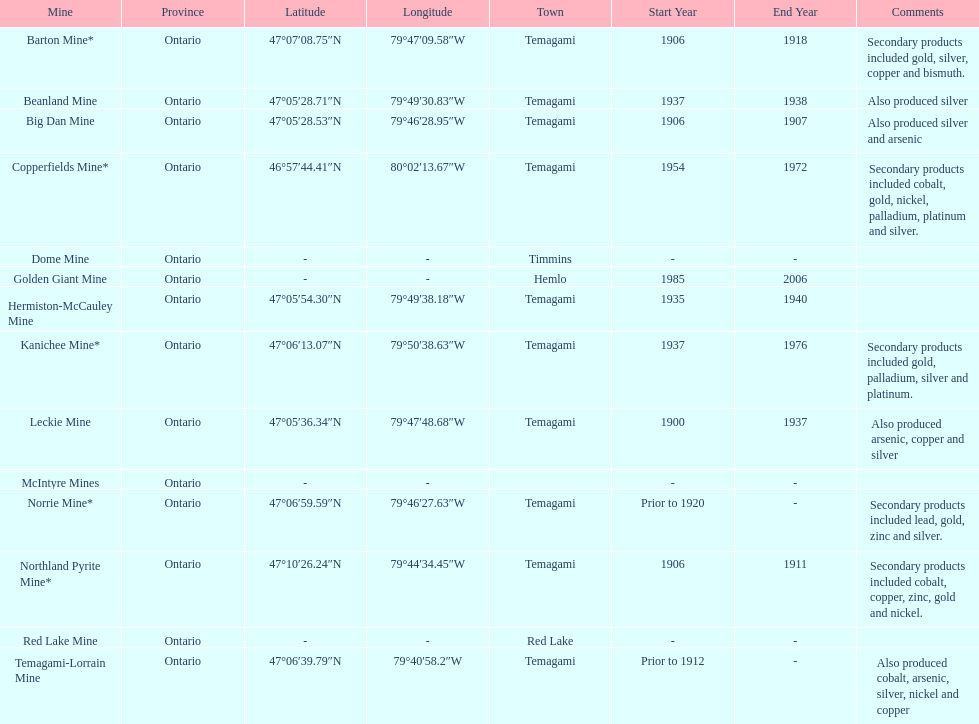Write the full table. {'header': ['Mine', 'Province', 'Latitude', 'Longitude', 'Town', 'Start Year', 'End Year', 'Comments'], 'rows': [['Barton Mine*', 'Ontario', '47°07′08.75″N', '79°47′09.58″W', 'Temagami', '1906', '1918', 'Secondary products included gold, silver, copper and bismuth.'], ['Beanland Mine', 'Ontario', '47°05′28.71″N', '79°49′30.83″W', 'Temagami', '1937', '1938', 'Also produced silver'], ['Big Dan Mine', 'Ontario', '47°05′28.53″N', '79°46′28.95″W', 'Temagami', '1906', '1907', 'Also produced silver and arsenic'], ['Copperfields Mine*', 'Ontario', '46°57′44.41″N', '80°02′13.67″W', 'Temagami', '1954', '1972', 'Secondary products included cobalt, gold, nickel, palladium, platinum and silver.'], ['Dome Mine', 'Ontario', '-', '-', 'Timmins', '-', '-', ''], ['Golden Giant Mine', 'Ontario', '-', '-', 'Hemlo', '1985', '2006', ''], ['Hermiston-McCauley Mine', 'Ontario', '47°05′54.30″N', '79°49′38.18″W', 'Temagami', '1935', '1940', ''], ['Kanichee Mine*', 'Ontario', '47°06′13.07″N', '79°50′38.63″W', 'Temagami', '1937', '1976', 'Secondary products included gold, palladium, silver and platinum.'], ['Leckie Mine', 'Ontario', '47°05′36.34″N', '79°47′48.68″W', 'Temagami', '1900', '1937', 'Also produced arsenic, copper and silver'], ['McIntyre Mines', 'Ontario', '-', '-', '', '-', '-', ''], ['Norrie Mine*', 'Ontario', '47°06′59.59″N', '79°46′27.63″W', 'Temagami', 'Prior to 1920', '-', 'Secondary products included lead, gold, zinc and silver.'], ['Northland Pyrite Mine*', 'Ontario', '47°10′26.24″N', '79°44′34.45″W', 'Temagami', '1906', '1911', 'Secondary products included cobalt, copper, zinc, gold and nickel.'], ['Red Lake Mine', 'Ontario', '-', '-', 'Red Lake', '-', '-', ''], ['Temagami-Lorrain Mine', 'Ontario', '47°06′39.79″N', '79°40′58.2″W', 'Temagami', 'Prior to 1912', '-', 'Also produced cobalt, arsenic, silver, nickel and copper']]} In what mine could you find bismuth? Barton Mine. 